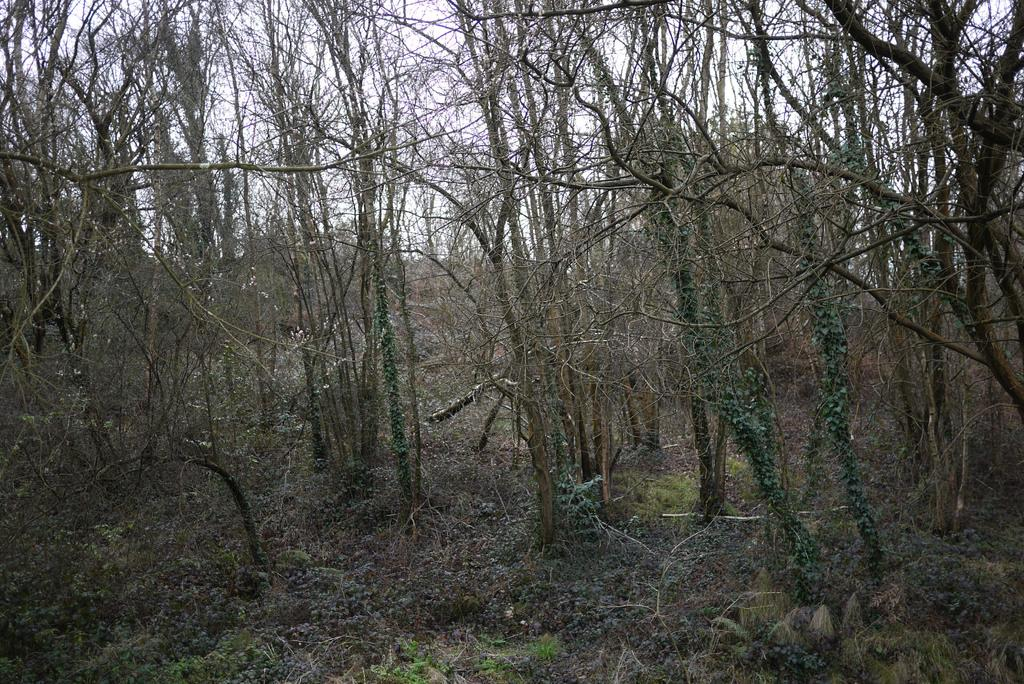What is the primary feature of the image? There are many trees in the image. What can be seen at the bottom of the image? At the bottom of the image, there are plants, grass, and stones. What is visible at the top of the image? The sky is visible at the top of the image. What type of science experiment is being conducted in the image? There is no science experiment present in the image; it primarily features trees, plants, grass, stones, and the sky. 